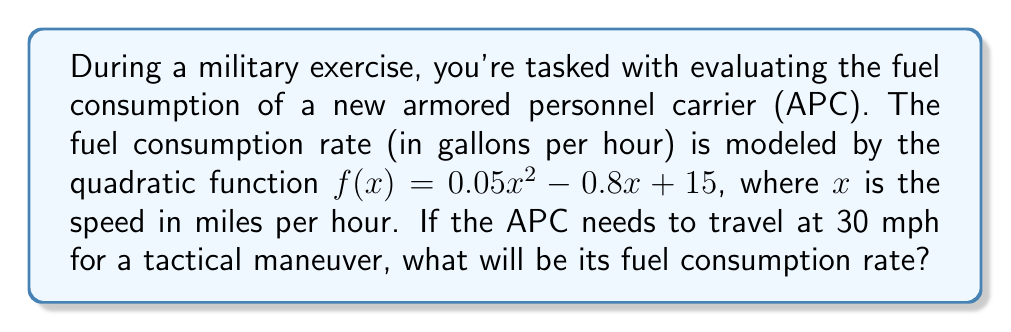Can you answer this question? To find the fuel consumption rate at 30 mph, we need to evaluate the quadratic function $f(x)$ at $x = 30$. Let's follow these steps:

1) The given quadratic function is:
   $f(x) = 0.05x^2 - 0.8x + 15$

2) We need to substitute $x = 30$ into this function:
   $f(30) = 0.05(30)^2 - 0.8(30) + 15$

3) Let's evaluate each term:
   - $0.05(30)^2 = 0.05(900) = 45$
   - $-0.8(30) = -24$
   - The constant term is already 15

4) Now, let's add these terms:
   $f(30) = 45 - 24 + 15 = 36$

Therefore, when the APC is traveling at 30 mph, its fuel consumption rate will be 36 gallons per hour.
Answer: 36 gallons per hour 